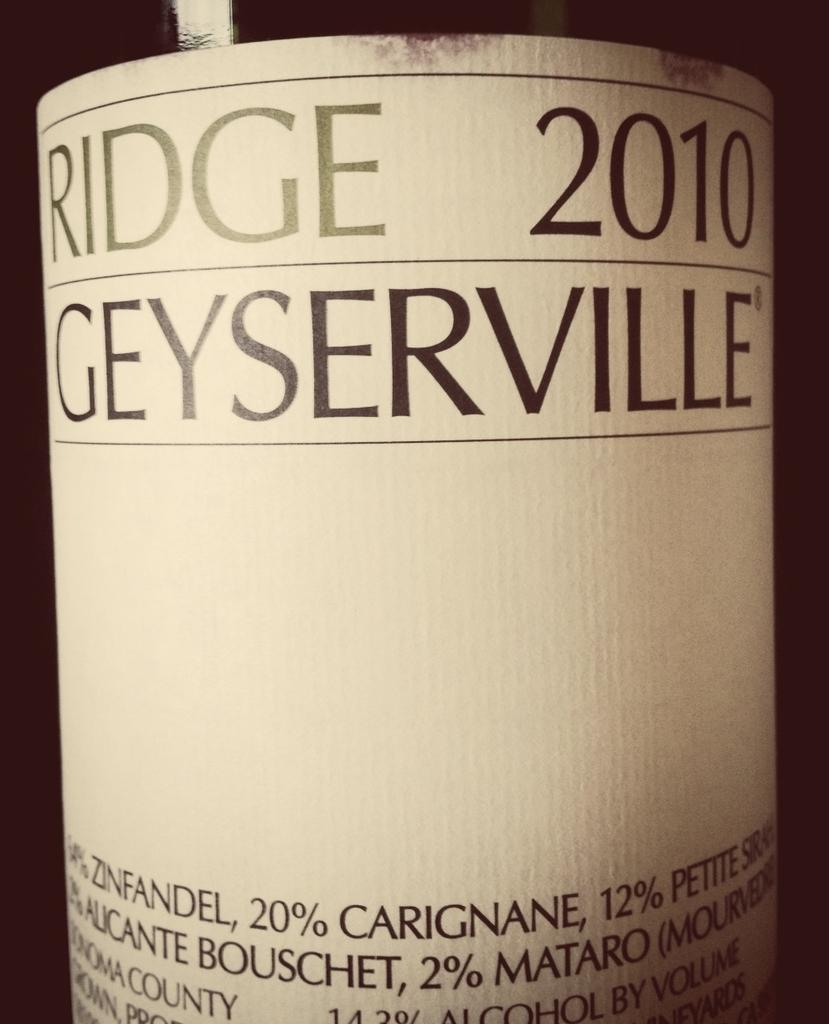<image>
Share a concise interpretation of the image provided. A close up of a bottle of Ridge 2010 Geyserville 